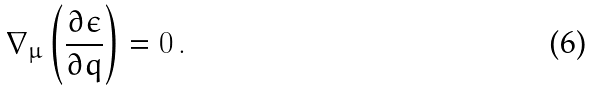<formula> <loc_0><loc_0><loc_500><loc_500>\nabla _ { \mu } \left ( \frac { \partial \epsilon } { \partial q } \right ) = 0 \, .</formula> 